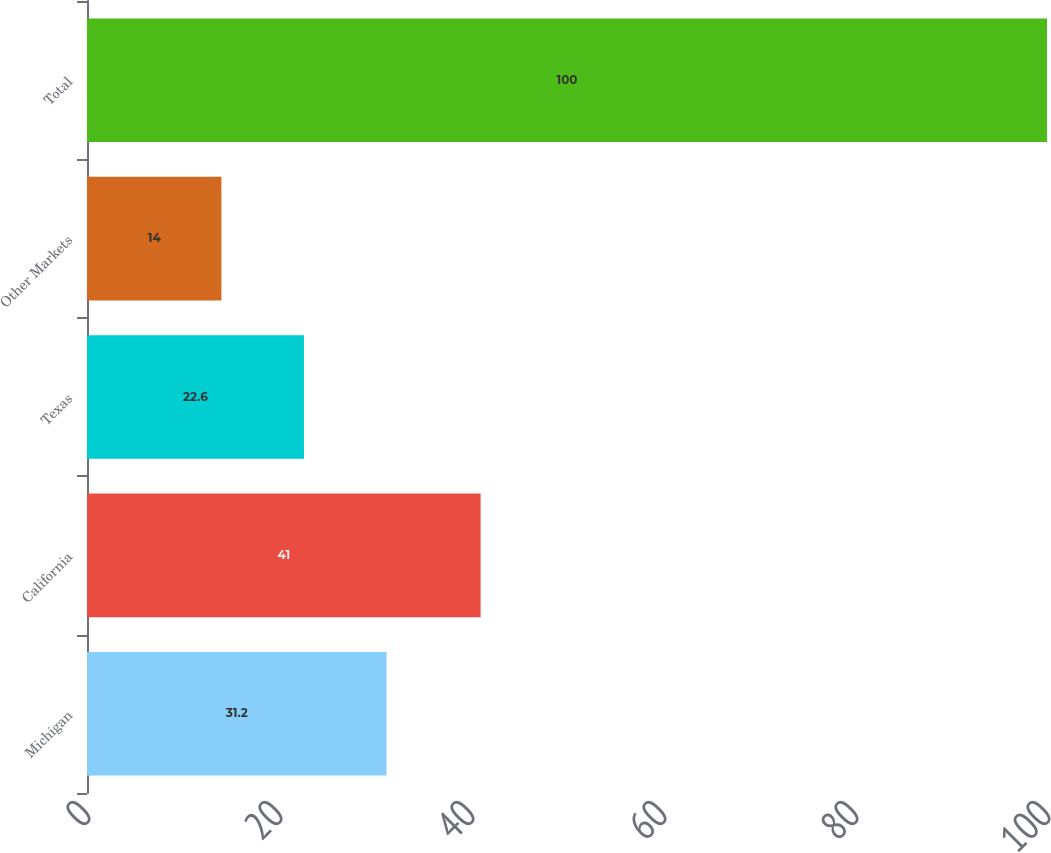Convert chart. <chart><loc_0><loc_0><loc_500><loc_500><bar_chart><fcel>Michigan<fcel>California<fcel>Texas<fcel>Other Markets<fcel>Total<nl><fcel>31.2<fcel>41<fcel>22.6<fcel>14<fcel>100<nl></chart> 